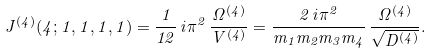<formula> <loc_0><loc_0><loc_500><loc_500>J ^ { ( 4 ) } ( 4 ; 1 , 1 , 1 , 1 ) = { \frac { 1 } { 1 2 } } \, i \pi ^ { 2 } \, \frac { \Omega ^ { ( 4 ) } } { V ^ { ( 4 ) } } = \frac { 2 \, i \pi ^ { 2 } } { m _ { 1 } m _ { 2 } m _ { 3 } m _ { 4 } } \, \frac { \Omega ^ { ( 4 ) } } { \sqrt { D ^ { ( 4 ) } } } .</formula> 